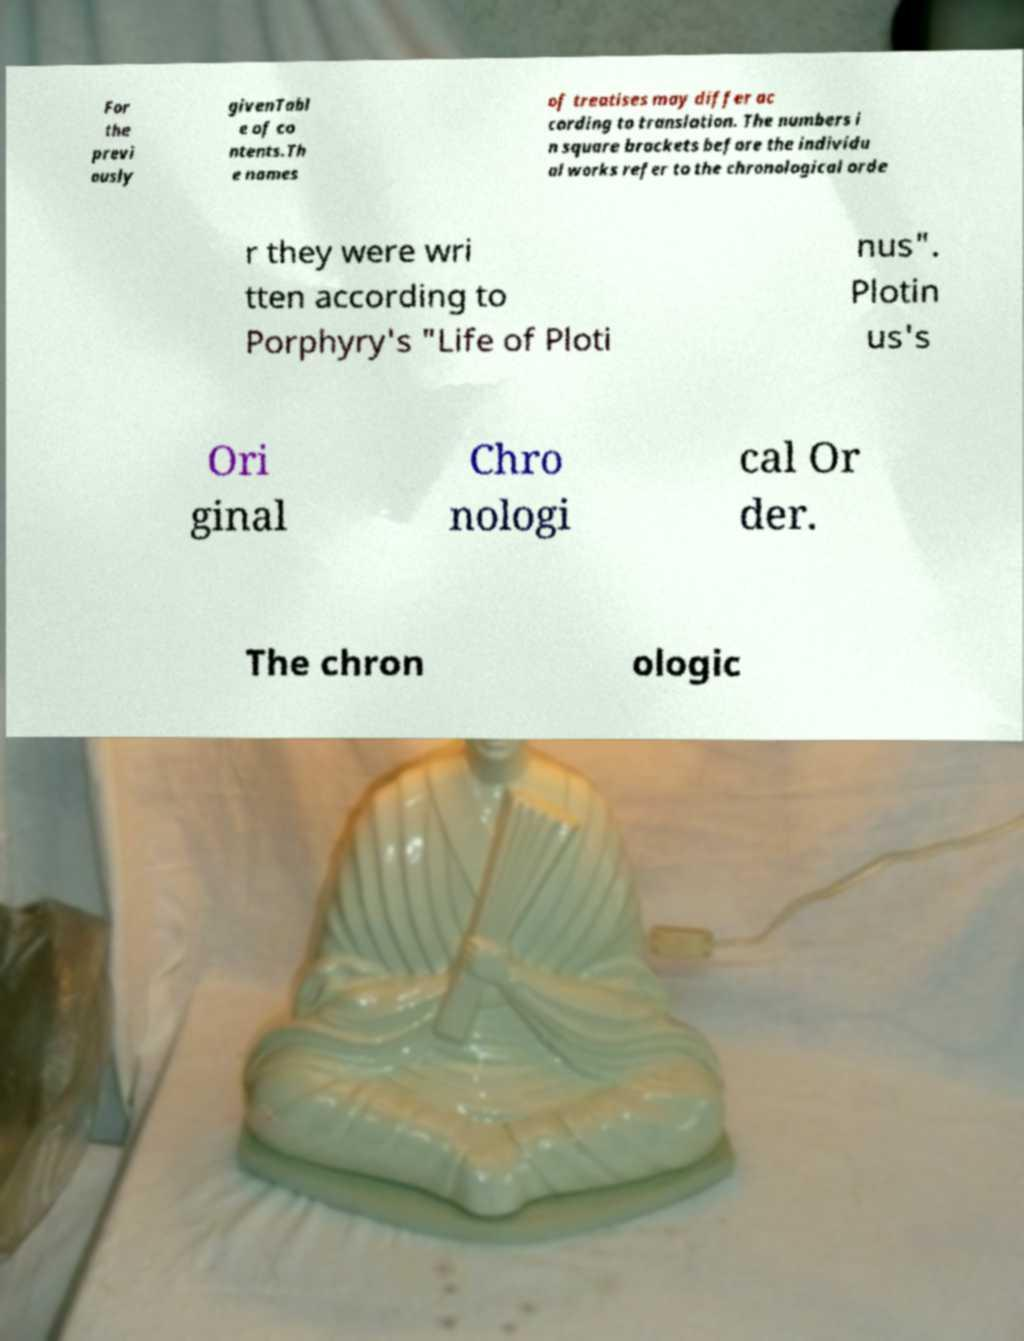Please identify and transcribe the text found in this image. For the previ ously givenTabl e of co ntents.Th e names of treatises may differ ac cording to translation. The numbers i n square brackets before the individu al works refer to the chronological orde r they were wri tten according to Porphyry's "Life of Ploti nus". Plotin us's Ori ginal Chro nologi cal Or der. The chron ologic 